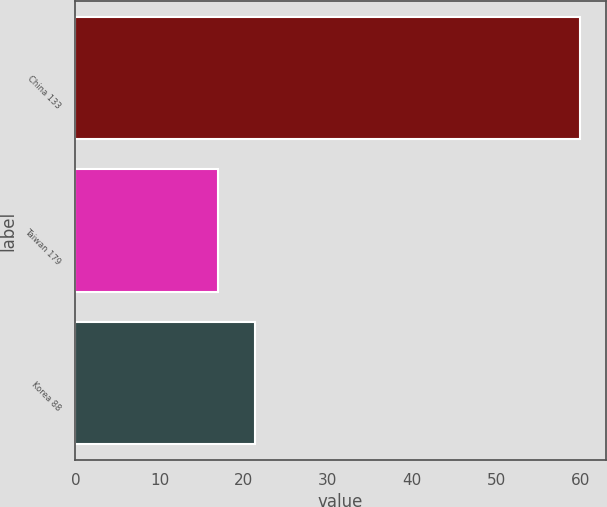<chart> <loc_0><loc_0><loc_500><loc_500><bar_chart><fcel>China 133<fcel>Taiwan 179<fcel>Korea 88<nl><fcel>60<fcel>17<fcel>21.3<nl></chart> 